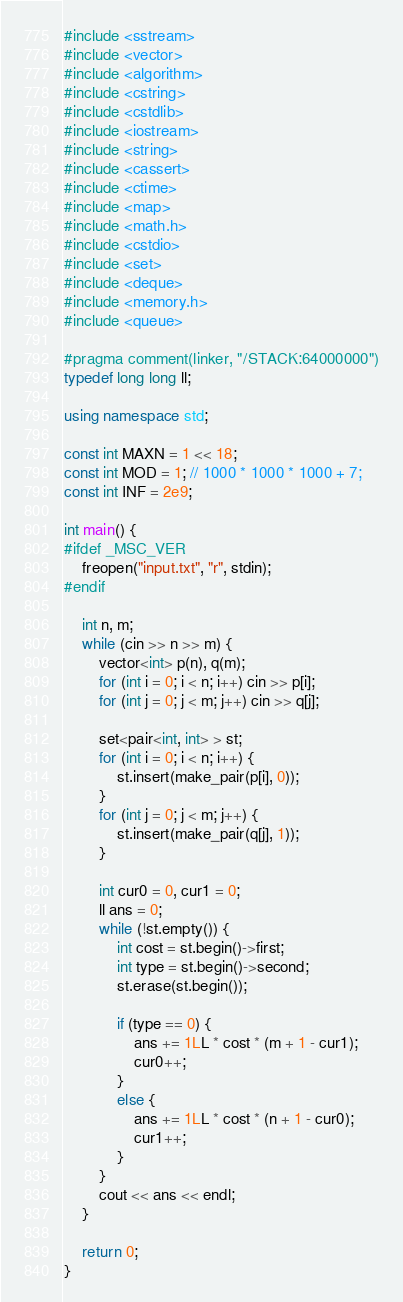<code> <loc_0><loc_0><loc_500><loc_500><_C++_>#include <sstream>
#include <vector>
#include <algorithm>
#include <cstring>
#include <cstdlib>
#include <iostream>
#include <string>
#include <cassert>
#include <ctime>
#include <map>
#include <math.h>
#include <cstdio>
#include <set>
#include <deque>
#include <memory.h>
#include <queue>

#pragma comment(linker, "/STACK:64000000")
typedef long long ll;

using namespace std;

const int MAXN = 1 << 18;
const int MOD = 1; // 1000 * 1000 * 1000 + 7;
const int INF = 2e9;

int main() {
#ifdef _MSC_VER
	freopen("input.txt", "r", stdin);
#endif

	int n, m;
	while (cin >> n >> m) {
		vector<int> p(n), q(m);
		for (int i = 0; i < n; i++) cin >> p[i];
		for (int j = 0; j < m; j++) cin >> q[j];

		set<pair<int, int> > st;
		for (int i = 0; i < n; i++) {
			st.insert(make_pair(p[i], 0));
		}
		for (int j = 0; j < m; j++) {
			st.insert(make_pair(q[j], 1));
		}

		int cur0 = 0, cur1 = 0;
		ll ans = 0;
		while (!st.empty()) {
			int cost = st.begin()->first;
			int type = st.begin()->second;
			st.erase(st.begin());

			if (type == 0) {
				ans += 1LL * cost * (m + 1 - cur1);
				cur0++;
			}
			else {
				ans += 1LL * cost * (n + 1 - cur0);
				cur1++;
			}
		}
		cout << ans << endl;
	}

	return 0;
}</code> 